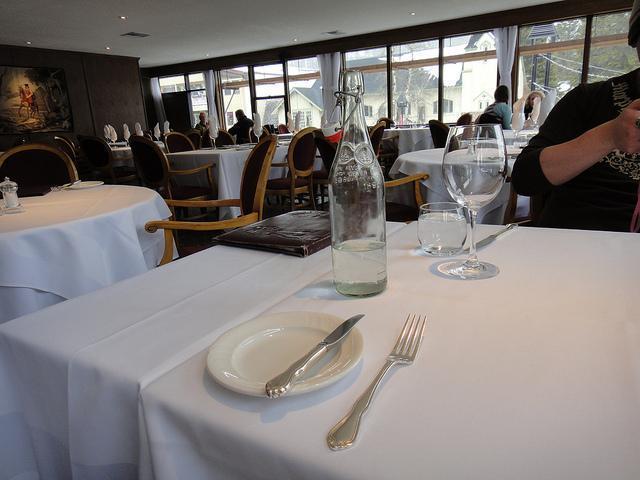How many glasses are there?
Give a very brief answer. 2. How many dining tables can be seen?
Give a very brief answer. 2. How many chairs are there?
Give a very brief answer. 5. How many cars are in this picture?
Give a very brief answer. 0. 